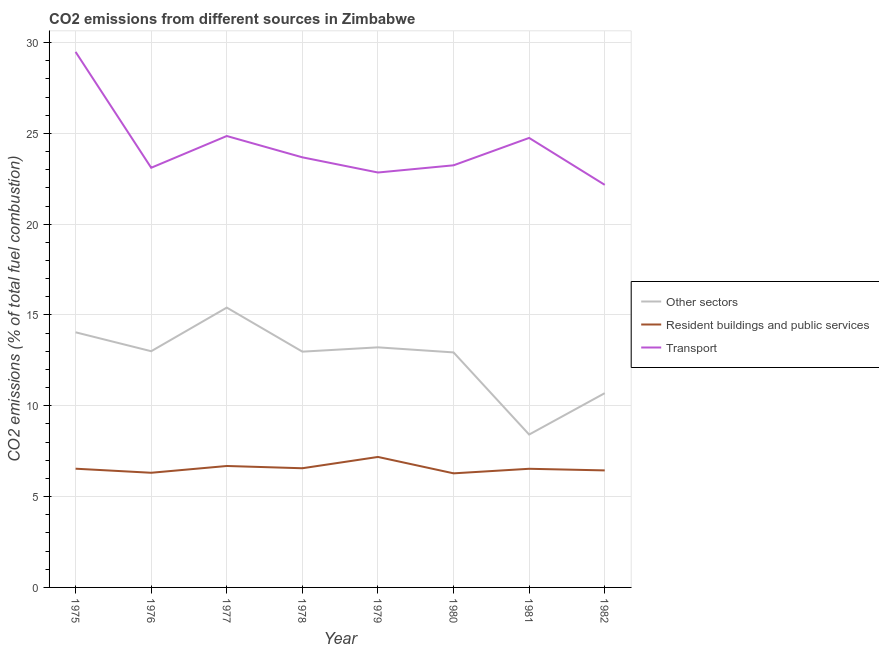Does the line corresponding to percentage of co2 emissions from other sectors intersect with the line corresponding to percentage of co2 emissions from resident buildings and public services?
Your answer should be compact. No. What is the percentage of co2 emissions from other sectors in 1977?
Your response must be concise. 15.41. Across all years, what is the maximum percentage of co2 emissions from other sectors?
Offer a terse response. 15.41. Across all years, what is the minimum percentage of co2 emissions from other sectors?
Your response must be concise. 8.42. In which year was the percentage of co2 emissions from transport maximum?
Provide a short and direct response. 1975. In which year was the percentage of co2 emissions from transport minimum?
Provide a short and direct response. 1982. What is the total percentage of co2 emissions from resident buildings and public services in the graph?
Offer a terse response. 52.54. What is the difference between the percentage of co2 emissions from transport in 1978 and that in 1982?
Give a very brief answer. 1.52. What is the difference between the percentage of co2 emissions from other sectors in 1981 and the percentage of co2 emissions from transport in 1982?
Keep it short and to the point. -13.75. What is the average percentage of co2 emissions from resident buildings and public services per year?
Your answer should be compact. 6.57. In the year 1975, what is the difference between the percentage of co2 emissions from resident buildings and public services and percentage of co2 emissions from other sectors?
Your answer should be very brief. -7.51. What is the ratio of the percentage of co2 emissions from resident buildings and public services in 1978 to that in 1981?
Provide a succinct answer. 1. Is the percentage of co2 emissions from transport in 1976 less than that in 1977?
Provide a short and direct response. Yes. Is the difference between the percentage of co2 emissions from resident buildings and public services in 1976 and 1981 greater than the difference between the percentage of co2 emissions from transport in 1976 and 1981?
Give a very brief answer. Yes. What is the difference between the highest and the second highest percentage of co2 emissions from resident buildings and public services?
Make the answer very short. 0.5. What is the difference between the highest and the lowest percentage of co2 emissions from transport?
Provide a short and direct response. 7.32. In how many years, is the percentage of co2 emissions from other sectors greater than the average percentage of co2 emissions from other sectors taken over all years?
Offer a very short reply. 6. Is it the case that in every year, the sum of the percentage of co2 emissions from other sectors and percentage of co2 emissions from resident buildings and public services is greater than the percentage of co2 emissions from transport?
Your response must be concise. No. Does the percentage of co2 emissions from resident buildings and public services monotonically increase over the years?
Offer a terse response. No. Is the percentage of co2 emissions from other sectors strictly less than the percentage of co2 emissions from transport over the years?
Your answer should be compact. Yes. How many lines are there?
Provide a succinct answer. 3. What is the difference between two consecutive major ticks on the Y-axis?
Your answer should be compact. 5. Are the values on the major ticks of Y-axis written in scientific E-notation?
Your response must be concise. No. Does the graph contain any zero values?
Offer a terse response. No. How are the legend labels stacked?
Keep it short and to the point. Vertical. What is the title of the graph?
Make the answer very short. CO2 emissions from different sources in Zimbabwe. What is the label or title of the Y-axis?
Offer a very short reply. CO2 emissions (% of total fuel combustion). What is the CO2 emissions (% of total fuel combustion) in Other sectors in 1975?
Keep it short and to the point. 14.05. What is the CO2 emissions (% of total fuel combustion) of Resident buildings and public services in 1975?
Your response must be concise. 6.54. What is the CO2 emissions (% of total fuel combustion) of Transport in 1975?
Keep it short and to the point. 29.49. What is the CO2 emissions (% of total fuel combustion) in Other sectors in 1976?
Provide a short and direct response. 13.01. What is the CO2 emissions (% of total fuel combustion) in Resident buildings and public services in 1976?
Provide a short and direct response. 6.31. What is the CO2 emissions (% of total fuel combustion) in Transport in 1976?
Keep it short and to the point. 23.11. What is the CO2 emissions (% of total fuel combustion) of Other sectors in 1977?
Your answer should be compact. 15.41. What is the CO2 emissions (% of total fuel combustion) in Resident buildings and public services in 1977?
Keep it short and to the point. 6.69. What is the CO2 emissions (% of total fuel combustion) of Transport in 1977?
Make the answer very short. 24.85. What is the CO2 emissions (% of total fuel combustion) in Other sectors in 1978?
Provide a short and direct response. 12.98. What is the CO2 emissions (% of total fuel combustion) in Resident buildings and public services in 1978?
Offer a very short reply. 6.56. What is the CO2 emissions (% of total fuel combustion) of Transport in 1978?
Provide a short and direct response. 23.68. What is the CO2 emissions (% of total fuel combustion) of Other sectors in 1979?
Keep it short and to the point. 13.22. What is the CO2 emissions (% of total fuel combustion) in Resident buildings and public services in 1979?
Your answer should be very brief. 7.18. What is the CO2 emissions (% of total fuel combustion) of Transport in 1979?
Your answer should be very brief. 22.84. What is the CO2 emissions (% of total fuel combustion) of Other sectors in 1980?
Make the answer very short. 12.94. What is the CO2 emissions (% of total fuel combustion) in Resident buildings and public services in 1980?
Offer a very short reply. 6.28. What is the CO2 emissions (% of total fuel combustion) in Transport in 1980?
Make the answer very short. 23.24. What is the CO2 emissions (% of total fuel combustion) of Other sectors in 1981?
Your response must be concise. 8.42. What is the CO2 emissions (% of total fuel combustion) of Resident buildings and public services in 1981?
Ensure brevity in your answer.  6.53. What is the CO2 emissions (% of total fuel combustion) in Transport in 1981?
Your response must be concise. 24.75. What is the CO2 emissions (% of total fuel combustion) of Other sectors in 1982?
Keep it short and to the point. 10.7. What is the CO2 emissions (% of total fuel combustion) of Resident buildings and public services in 1982?
Ensure brevity in your answer.  6.44. What is the CO2 emissions (% of total fuel combustion) in Transport in 1982?
Offer a very short reply. 22.16. Across all years, what is the maximum CO2 emissions (% of total fuel combustion) of Other sectors?
Your response must be concise. 15.41. Across all years, what is the maximum CO2 emissions (% of total fuel combustion) of Resident buildings and public services?
Make the answer very short. 7.18. Across all years, what is the maximum CO2 emissions (% of total fuel combustion) of Transport?
Your answer should be compact. 29.49. Across all years, what is the minimum CO2 emissions (% of total fuel combustion) of Other sectors?
Your answer should be very brief. 8.42. Across all years, what is the minimum CO2 emissions (% of total fuel combustion) in Resident buildings and public services?
Offer a very short reply. 6.28. Across all years, what is the minimum CO2 emissions (% of total fuel combustion) of Transport?
Ensure brevity in your answer.  22.16. What is the total CO2 emissions (% of total fuel combustion) of Other sectors in the graph?
Your response must be concise. 100.71. What is the total CO2 emissions (% of total fuel combustion) in Resident buildings and public services in the graph?
Your answer should be compact. 52.54. What is the total CO2 emissions (% of total fuel combustion) in Transport in the graph?
Offer a terse response. 194.13. What is the difference between the CO2 emissions (% of total fuel combustion) of Other sectors in 1975 and that in 1976?
Offer a very short reply. 1.04. What is the difference between the CO2 emissions (% of total fuel combustion) in Resident buildings and public services in 1975 and that in 1976?
Give a very brief answer. 0.22. What is the difference between the CO2 emissions (% of total fuel combustion) of Transport in 1975 and that in 1976?
Your answer should be very brief. 6.38. What is the difference between the CO2 emissions (% of total fuel combustion) in Other sectors in 1975 and that in 1977?
Make the answer very short. -1.36. What is the difference between the CO2 emissions (% of total fuel combustion) in Resident buildings and public services in 1975 and that in 1977?
Ensure brevity in your answer.  -0.15. What is the difference between the CO2 emissions (% of total fuel combustion) of Transport in 1975 and that in 1977?
Keep it short and to the point. 4.63. What is the difference between the CO2 emissions (% of total fuel combustion) of Other sectors in 1975 and that in 1978?
Offer a very short reply. 1.07. What is the difference between the CO2 emissions (% of total fuel combustion) of Resident buildings and public services in 1975 and that in 1978?
Provide a succinct answer. -0.03. What is the difference between the CO2 emissions (% of total fuel combustion) of Transport in 1975 and that in 1978?
Make the answer very short. 5.8. What is the difference between the CO2 emissions (% of total fuel combustion) in Other sectors in 1975 and that in 1979?
Provide a short and direct response. 0.83. What is the difference between the CO2 emissions (% of total fuel combustion) in Resident buildings and public services in 1975 and that in 1979?
Offer a terse response. -0.65. What is the difference between the CO2 emissions (% of total fuel combustion) of Transport in 1975 and that in 1979?
Make the answer very short. 6.64. What is the difference between the CO2 emissions (% of total fuel combustion) in Other sectors in 1975 and that in 1980?
Offer a very short reply. 1.11. What is the difference between the CO2 emissions (% of total fuel combustion) of Resident buildings and public services in 1975 and that in 1980?
Your answer should be very brief. 0.26. What is the difference between the CO2 emissions (% of total fuel combustion) of Transport in 1975 and that in 1980?
Your answer should be compact. 6.24. What is the difference between the CO2 emissions (% of total fuel combustion) of Other sectors in 1975 and that in 1981?
Ensure brevity in your answer.  5.63. What is the difference between the CO2 emissions (% of total fuel combustion) of Resident buildings and public services in 1975 and that in 1981?
Offer a terse response. 0. What is the difference between the CO2 emissions (% of total fuel combustion) in Transport in 1975 and that in 1981?
Your answer should be very brief. 4.74. What is the difference between the CO2 emissions (% of total fuel combustion) in Other sectors in 1975 and that in 1982?
Keep it short and to the point. 3.35. What is the difference between the CO2 emissions (% of total fuel combustion) in Resident buildings and public services in 1975 and that in 1982?
Your answer should be very brief. 0.09. What is the difference between the CO2 emissions (% of total fuel combustion) of Transport in 1975 and that in 1982?
Provide a succinct answer. 7.32. What is the difference between the CO2 emissions (% of total fuel combustion) of Other sectors in 1976 and that in 1977?
Your answer should be very brief. -2.4. What is the difference between the CO2 emissions (% of total fuel combustion) of Resident buildings and public services in 1976 and that in 1977?
Keep it short and to the point. -0.37. What is the difference between the CO2 emissions (% of total fuel combustion) of Transport in 1976 and that in 1977?
Your response must be concise. -1.75. What is the difference between the CO2 emissions (% of total fuel combustion) in Other sectors in 1976 and that in 1978?
Ensure brevity in your answer.  0.02. What is the difference between the CO2 emissions (% of total fuel combustion) in Resident buildings and public services in 1976 and that in 1978?
Offer a terse response. -0.25. What is the difference between the CO2 emissions (% of total fuel combustion) in Transport in 1976 and that in 1978?
Offer a very short reply. -0.57. What is the difference between the CO2 emissions (% of total fuel combustion) in Other sectors in 1976 and that in 1979?
Make the answer very short. -0.21. What is the difference between the CO2 emissions (% of total fuel combustion) in Resident buildings and public services in 1976 and that in 1979?
Your answer should be very brief. -0.87. What is the difference between the CO2 emissions (% of total fuel combustion) in Transport in 1976 and that in 1979?
Offer a terse response. 0.26. What is the difference between the CO2 emissions (% of total fuel combustion) in Other sectors in 1976 and that in 1980?
Your response must be concise. 0.07. What is the difference between the CO2 emissions (% of total fuel combustion) of Resident buildings and public services in 1976 and that in 1980?
Keep it short and to the point. 0.03. What is the difference between the CO2 emissions (% of total fuel combustion) of Transport in 1976 and that in 1980?
Provide a succinct answer. -0.14. What is the difference between the CO2 emissions (% of total fuel combustion) of Other sectors in 1976 and that in 1981?
Your answer should be compact. 4.59. What is the difference between the CO2 emissions (% of total fuel combustion) in Resident buildings and public services in 1976 and that in 1981?
Your answer should be compact. -0.22. What is the difference between the CO2 emissions (% of total fuel combustion) in Transport in 1976 and that in 1981?
Your answer should be compact. -1.64. What is the difference between the CO2 emissions (% of total fuel combustion) of Other sectors in 1976 and that in 1982?
Your answer should be compact. 2.31. What is the difference between the CO2 emissions (% of total fuel combustion) of Resident buildings and public services in 1976 and that in 1982?
Provide a short and direct response. -0.13. What is the difference between the CO2 emissions (% of total fuel combustion) in Transport in 1976 and that in 1982?
Offer a very short reply. 0.94. What is the difference between the CO2 emissions (% of total fuel combustion) in Other sectors in 1977 and that in 1978?
Offer a very short reply. 2.43. What is the difference between the CO2 emissions (% of total fuel combustion) of Resident buildings and public services in 1977 and that in 1978?
Provide a short and direct response. 0.12. What is the difference between the CO2 emissions (% of total fuel combustion) in Transport in 1977 and that in 1978?
Your response must be concise. 1.17. What is the difference between the CO2 emissions (% of total fuel combustion) in Other sectors in 1977 and that in 1979?
Your answer should be very brief. 2.19. What is the difference between the CO2 emissions (% of total fuel combustion) of Resident buildings and public services in 1977 and that in 1979?
Ensure brevity in your answer.  -0.5. What is the difference between the CO2 emissions (% of total fuel combustion) of Transport in 1977 and that in 1979?
Give a very brief answer. 2.01. What is the difference between the CO2 emissions (% of total fuel combustion) of Other sectors in 1977 and that in 1980?
Offer a terse response. 2.47. What is the difference between the CO2 emissions (% of total fuel combustion) of Resident buildings and public services in 1977 and that in 1980?
Provide a succinct answer. 0.4. What is the difference between the CO2 emissions (% of total fuel combustion) in Transport in 1977 and that in 1980?
Give a very brief answer. 1.61. What is the difference between the CO2 emissions (% of total fuel combustion) of Other sectors in 1977 and that in 1981?
Provide a short and direct response. 6.99. What is the difference between the CO2 emissions (% of total fuel combustion) in Resident buildings and public services in 1977 and that in 1981?
Make the answer very short. 0.15. What is the difference between the CO2 emissions (% of total fuel combustion) in Transport in 1977 and that in 1981?
Your answer should be compact. 0.11. What is the difference between the CO2 emissions (% of total fuel combustion) in Other sectors in 1977 and that in 1982?
Ensure brevity in your answer.  4.71. What is the difference between the CO2 emissions (% of total fuel combustion) of Resident buildings and public services in 1977 and that in 1982?
Give a very brief answer. 0.24. What is the difference between the CO2 emissions (% of total fuel combustion) of Transport in 1977 and that in 1982?
Offer a very short reply. 2.69. What is the difference between the CO2 emissions (% of total fuel combustion) in Other sectors in 1978 and that in 1979?
Keep it short and to the point. -0.24. What is the difference between the CO2 emissions (% of total fuel combustion) in Resident buildings and public services in 1978 and that in 1979?
Make the answer very short. -0.62. What is the difference between the CO2 emissions (% of total fuel combustion) of Transport in 1978 and that in 1979?
Your answer should be very brief. 0.84. What is the difference between the CO2 emissions (% of total fuel combustion) in Other sectors in 1978 and that in 1980?
Keep it short and to the point. 0.04. What is the difference between the CO2 emissions (% of total fuel combustion) of Resident buildings and public services in 1978 and that in 1980?
Ensure brevity in your answer.  0.28. What is the difference between the CO2 emissions (% of total fuel combustion) in Transport in 1978 and that in 1980?
Your answer should be compact. 0.44. What is the difference between the CO2 emissions (% of total fuel combustion) in Other sectors in 1978 and that in 1981?
Keep it short and to the point. 4.56. What is the difference between the CO2 emissions (% of total fuel combustion) in Resident buildings and public services in 1978 and that in 1981?
Your answer should be very brief. 0.03. What is the difference between the CO2 emissions (% of total fuel combustion) in Transport in 1978 and that in 1981?
Provide a succinct answer. -1.07. What is the difference between the CO2 emissions (% of total fuel combustion) of Other sectors in 1978 and that in 1982?
Make the answer very short. 2.29. What is the difference between the CO2 emissions (% of total fuel combustion) in Resident buildings and public services in 1978 and that in 1982?
Your answer should be compact. 0.12. What is the difference between the CO2 emissions (% of total fuel combustion) of Transport in 1978 and that in 1982?
Ensure brevity in your answer.  1.52. What is the difference between the CO2 emissions (% of total fuel combustion) in Other sectors in 1979 and that in 1980?
Your answer should be very brief. 0.28. What is the difference between the CO2 emissions (% of total fuel combustion) in Resident buildings and public services in 1979 and that in 1980?
Your answer should be very brief. 0.9. What is the difference between the CO2 emissions (% of total fuel combustion) in Transport in 1979 and that in 1980?
Your response must be concise. -0.4. What is the difference between the CO2 emissions (% of total fuel combustion) in Other sectors in 1979 and that in 1981?
Offer a terse response. 4.8. What is the difference between the CO2 emissions (% of total fuel combustion) in Resident buildings and public services in 1979 and that in 1981?
Provide a short and direct response. 0.65. What is the difference between the CO2 emissions (% of total fuel combustion) of Transport in 1979 and that in 1981?
Offer a very short reply. -1.9. What is the difference between the CO2 emissions (% of total fuel combustion) of Other sectors in 1979 and that in 1982?
Ensure brevity in your answer.  2.52. What is the difference between the CO2 emissions (% of total fuel combustion) in Resident buildings and public services in 1979 and that in 1982?
Give a very brief answer. 0.74. What is the difference between the CO2 emissions (% of total fuel combustion) in Transport in 1979 and that in 1982?
Keep it short and to the point. 0.68. What is the difference between the CO2 emissions (% of total fuel combustion) of Other sectors in 1980 and that in 1981?
Offer a terse response. 4.52. What is the difference between the CO2 emissions (% of total fuel combustion) of Resident buildings and public services in 1980 and that in 1981?
Offer a terse response. -0.25. What is the difference between the CO2 emissions (% of total fuel combustion) in Transport in 1980 and that in 1981?
Your response must be concise. -1.51. What is the difference between the CO2 emissions (% of total fuel combustion) in Other sectors in 1980 and that in 1982?
Offer a very short reply. 2.24. What is the difference between the CO2 emissions (% of total fuel combustion) of Resident buildings and public services in 1980 and that in 1982?
Provide a short and direct response. -0.16. What is the difference between the CO2 emissions (% of total fuel combustion) of Transport in 1980 and that in 1982?
Make the answer very short. 1.08. What is the difference between the CO2 emissions (% of total fuel combustion) of Other sectors in 1981 and that in 1982?
Provide a short and direct response. -2.28. What is the difference between the CO2 emissions (% of total fuel combustion) in Resident buildings and public services in 1981 and that in 1982?
Your answer should be very brief. 0.09. What is the difference between the CO2 emissions (% of total fuel combustion) in Transport in 1981 and that in 1982?
Offer a terse response. 2.58. What is the difference between the CO2 emissions (% of total fuel combustion) in Other sectors in 1975 and the CO2 emissions (% of total fuel combustion) in Resident buildings and public services in 1976?
Ensure brevity in your answer.  7.73. What is the difference between the CO2 emissions (% of total fuel combustion) in Other sectors in 1975 and the CO2 emissions (% of total fuel combustion) in Transport in 1976?
Ensure brevity in your answer.  -9.06. What is the difference between the CO2 emissions (% of total fuel combustion) of Resident buildings and public services in 1975 and the CO2 emissions (% of total fuel combustion) of Transport in 1976?
Provide a succinct answer. -16.57. What is the difference between the CO2 emissions (% of total fuel combustion) of Other sectors in 1975 and the CO2 emissions (% of total fuel combustion) of Resident buildings and public services in 1977?
Make the answer very short. 7.36. What is the difference between the CO2 emissions (% of total fuel combustion) in Other sectors in 1975 and the CO2 emissions (% of total fuel combustion) in Transport in 1977?
Give a very brief answer. -10.81. What is the difference between the CO2 emissions (% of total fuel combustion) in Resident buildings and public services in 1975 and the CO2 emissions (% of total fuel combustion) in Transport in 1977?
Your response must be concise. -18.32. What is the difference between the CO2 emissions (% of total fuel combustion) in Other sectors in 1975 and the CO2 emissions (% of total fuel combustion) in Resident buildings and public services in 1978?
Your response must be concise. 7.49. What is the difference between the CO2 emissions (% of total fuel combustion) of Other sectors in 1975 and the CO2 emissions (% of total fuel combustion) of Transport in 1978?
Offer a terse response. -9.63. What is the difference between the CO2 emissions (% of total fuel combustion) of Resident buildings and public services in 1975 and the CO2 emissions (% of total fuel combustion) of Transport in 1978?
Your answer should be compact. -17.14. What is the difference between the CO2 emissions (% of total fuel combustion) in Other sectors in 1975 and the CO2 emissions (% of total fuel combustion) in Resident buildings and public services in 1979?
Provide a succinct answer. 6.86. What is the difference between the CO2 emissions (% of total fuel combustion) in Other sectors in 1975 and the CO2 emissions (% of total fuel combustion) in Transport in 1979?
Your response must be concise. -8.8. What is the difference between the CO2 emissions (% of total fuel combustion) in Resident buildings and public services in 1975 and the CO2 emissions (% of total fuel combustion) in Transport in 1979?
Your answer should be compact. -16.31. What is the difference between the CO2 emissions (% of total fuel combustion) in Other sectors in 1975 and the CO2 emissions (% of total fuel combustion) in Resident buildings and public services in 1980?
Provide a short and direct response. 7.77. What is the difference between the CO2 emissions (% of total fuel combustion) in Other sectors in 1975 and the CO2 emissions (% of total fuel combustion) in Transport in 1980?
Your answer should be very brief. -9.19. What is the difference between the CO2 emissions (% of total fuel combustion) of Resident buildings and public services in 1975 and the CO2 emissions (% of total fuel combustion) of Transport in 1980?
Offer a terse response. -16.7. What is the difference between the CO2 emissions (% of total fuel combustion) in Other sectors in 1975 and the CO2 emissions (% of total fuel combustion) in Resident buildings and public services in 1981?
Ensure brevity in your answer.  7.51. What is the difference between the CO2 emissions (% of total fuel combustion) of Other sectors in 1975 and the CO2 emissions (% of total fuel combustion) of Transport in 1981?
Offer a terse response. -10.7. What is the difference between the CO2 emissions (% of total fuel combustion) of Resident buildings and public services in 1975 and the CO2 emissions (% of total fuel combustion) of Transport in 1981?
Offer a terse response. -18.21. What is the difference between the CO2 emissions (% of total fuel combustion) of Other sectors in 1975 and the CO2 emissions (% of total fuel combustion) of Resident buildings and public services in 1982?
Keep it short and to the point. 7.6. What is the difference between the CO2 emissions (% of total fuel combustion) of Other sectors in 1975 and the CO2 emissions (% of total fuel combustion) of Transport in 1982?
Ensure brevity in your answer.  -8.12. What is the difference between the CO2 emissions (% of total fuel combustion) of Resident buildings and public services in 1975 and the CO2 emissions (% of total fuel combustion) of Transport in 1982?
Your answer should be compact. -15.63. What is the difference between the CO2 emissions (% of total fuel combustion) in Other sectors in 1976 and the CO2 emissions (% of total fuel combustion) in Resident buildings and public services in 1977?
Your answer should be compact. 6.32. What is the difference between the CO2 emissions (% of total fuel combustion) in Other sectors in 1976 and the CO2 emissions (% of total fuel combustion) in Transport in 1977?
Make the answer very short. -11.85. What is the difference between the CO2 emissions (% of total fuel combustion) of Resident buildings and public services in 1976 and the CO2 emissions (% of total fuel combustion) of Transport in 1977?
Your response must be concise. -18.54. What is the difference between the CO2 emissions (% of total fuel combustion) in Other sectors in 1976 and the CO2 emissions (% of total fuel combustion) in Resident buildings and public services in 1978?
Offer a terse response. 6.44. What is the difference between the CO2 emissions (% of total fuel combustion) in Other sectors in 1976 and the CO2 emissions (% of total fuel combustion) in Transport in 1978?
Keep it short and to the point. -10.68. What is the difference between the CO2 emissions (% of total fuel combustion) of Resident buildings and public services in 1976 and the CO2 emissions (% of total fuel combustion) of Transport in 1978?
Your answer should be very brief. -17.37. What is the difference between the CO2 emissions (% of total fuel combustion) in Other sectors in 1976 and the CO2 emissions (% of total fuel combustion) in Resident buildings and public services in 1979?
Provide a succinct answer. 5.82. What is the difference between the CO2 emissions (% of total fuel combustion) in Other sectors in 1976 and the CO2 emissions (% of total fuel combustion) in Transport in 1979?
Offer a terse response. -9.84. What is the difference between the CO2 emissions (% of total fuel combustion) in Resident buildings and public services in 1976 and the CO2 emissions (% of total fuel combustion) in Transport in 1979?
Offer a very short reply. -16.53. What is the difference between the CO2 emissions (% of total fuel combustion) in Other sectors in 1976 and the CO2 emissions (% of total fuel combustion) in Resident buildings and public services in 1980?
Give a very brief answer. 6.72. What is the difference between the CO2 emissions (% of total fuel combustion) in Other sectors in 1976 and the CO2 emissions (% of total fuel combustion) in Transport in 1980?
Your answer should be compact. -10.24. What is the difference between the CO2 emissions (% of total fuel combustion) in Resident buildings and public services in 1976 and the CO2 emissions (% of total fuel combustion) in Transport in 1980?
Ensure brevity in your answer.  -16.93. What is the difference between the CO2 emissions (% of total fuel combustion) in Other sectors in 1976 and the CO2 emissions (% of total fuel combustion) in Resident buildings and public services in 1981?
Offer a very short reply. 6.47. What is the difference between the CO2 emissions (% of total fuel combustion) of Other sectors in 1976 and the CO2 emissions (% of total fuel combustion) of Transport in 1981?
Ensure brevity in your answer.  -11.74. What is the difference between the CO2 emissions (% of total fuel combustion) in Resident buildings and public services in 1976 and the CO2 emissions (% of total fuel combustion) in Transport in 1981?
Offer a terse response. -18.44. What is the difference between the CO2 emissions (% of total fuel combustion) in Other sectors in 1976 and the CO2 emissions (% of total fuel combustion) in Resident buildings and public services in 1982?
Offer a terse response. 6.56. What is the difference between the CO2 emissions (% of total fuel combustion) in Other sectors in 1976 and the CO2 emissions (% of total fuel combustion) in Transport in 1982?
Your answer should be compact. -9.16. What is the difference between the CO2 emissions (% of total fuel combustion) in Resident buildings and public services in 1976 and the CO2 emissions (% of total fuel combustion) in Transport in 1982?
Provide a succinct answer. -15.85. What is the difference between the CO2 emissions (% of total fuel combustion) in Other sectors in 1977 and the CO2 emissions (% of total fuel combustion) in Resident buildings and public services in 1978?
Offer a very short reply. 8.84. What is the difference between the CO2 emissions (% of total fuel combustion) of Other sectors in 1977 and the CO2 emissions (% of total fuel combustion) of Transport in 1978?
Your answer should be compact. -8.27. What is the difference between the CO2 emissions (% of total fuel combustion) in Resident buildings and public services in 1977 and the CO2 emissions (% of total fuel combustion) in Transport in 1978?
Make the answer very short. -16.99. What is the difference between the CO2 emissions (% of total fuel combustion) in Other sectors in 1977 and the CO2 emissions (% of total fuel combustion) in Resident buildings and public services in 1979?
Your response must be concise. 8.22. What is the difference between the CO2 emissions (% of total fuel combustion) in Other sectors in 1977 and the CO2 emissions (% of total fuel combustion) in Transport in 1979?
Your response must be concise. -7.44. What is the difference between the CO2 emissions (% of total fuel combustion) of Resident buildings and public services in 1977 and the CO2 emissions (% of total fuel combustion) of Transport in 1979?
Keep it short and to the point. -16.16. What is the difference between the CO2 emissions (% of total fuel combustion) of Other sectors in 1977 and the CO2 emissions (% of total fuel combustion) of Resident buildings and public services in 1980?
Make the answer very short. 9.13. What is the difference between the CO2 emissions (% of total fuel combustion) in Other sectors in 1977 and the CO2 emissions (% of total fuel combustion) in Transport in 1980?
Your response must be concise. -7.83. What is the difference between the CO2 emissions (% of total fuel combustion) in Resident buildings and public services in 1977 and the CO2 emissions (% of total fuel combustion) in Transport in 1980?
Keep it short and to the point. -16.56. What is the difference between the CO2 emissions (% of total fuel combustion) of Other sectors in 1977 and the CO2 emissions (% of total fuel combustion) of Resident buildings and public services in 1981?
Your response must be concise. 8.87. What is the difference between the CO2 emissions (% of total fuel combustion) of Other sectors in 1977 and the CO2 emissions (% of total fuel combustion) of Transport in 1981?
Keep it short and to the point. -9.34. What is the difference between the CO2 emissions (% of total fuel combustion) of Resident buildings and public services in 1977 and the CO2 emissions (% of total fuel combustion) of Transport in 1981?
Provide a succinct answer. -18.06. What is the difference between the CO2 emissions (% of total fuel combustion) of Other sectors in 1977 and the CO2 emissions (% of total fuel combustion) of Resident buildings and public services in 1982?
Offer a terse response. 8.96. What is the difference between the CO2 emissions (% of total fuel combustion) in Other sectors in 1977 and the CO2 emissions (% of total fuel combustion) in Transport in 1982?
Make the answer very short. -6.76. What is the difference between the CO2 emissions (% of total fuel combustion) in Resident buildings and public services in 1977 and the CO2 emissions (% of total fuel combustion) in Transport in 1982?
Provide a succinct answer. -15.48. What is the difference between the CO2 emissions (% of total fuel combustion) in Other sectors in 1978 and the CO2 emissions (% of total fuel combustion) in Resident buildings and public services in 1979?
Offer a very short reply. 5.8. What is the difference between the CO2 emissions (% of total fuel combustion) of Other sectors in 1978 and the CO2 emissions (% of total fuel combustion) of Transport in 1979?
Your answer should be very brief. -9.86. What is the difference between the CO2 emissions (% of total fuel combustion) in Resident buildings and public services in 1978 and the CO2 emissions (% of total fuel combustion) in Transport in 1979?
Provide a succinct answer. -16.28. What is the difference between the CO2 emissions (% of total fuel combustion) in Other sectors in 1978 and the CO2 emissions (% of total fuel combustion) in Resident buildings and public services in 1980?
Your answer should be very brief. 6.7. What is the difference between the CO2 emissions (% of total fuel combustion) in Other sectors in 1978 and the CO2 emissions (% of total fuel combustion) in Transport in 1980?
Your answer should be very brief. -10.26. What is the difference between the CO2 emissions (% of total fuel combustion) of Resident buildings and public services in 1978 and the CO2 emissions (% of total fuel combustion) of Transport in 1980?
Provide a succinct answer. -16.68. What is the difference between the CO2 emissions (% of total fuel combustion) of Other sectors in 1978 and the CO2 emissions (% of total fuel combustion) of Resident buildings and public services in 1981?
Offer a terse response. 6.45. What is the difference between the CO2 emissions (% of total fuel combustion) in Other sectors in 1978 and the CO2 emissions (% of total fuel combustion) in Transport in 1981?
Offer a very short reply. -11.77. What is the difference between the CO2 emissions (% of total fuel combustion) of Resident buildings and public services in 1978 and the CO2 emissions (% of total fuel combustion) of Transport in 1981?
Provide a short and direct response. -18.19. What is the difference between the CO2 emissions (% of total fuel combustion) in Other sectors in 1978 and the CO2 emissions (% of total fuel combustion) in Resident buildings and public services in 1982?
Your answer should be very brief. 6.54. What is the difference between the CO2 emissions (% of total fuel combustion) in Other sectors in 1978 and the CO2 emissions (% of total fuel combustion) in Transport in 1982?
Ensure brevity in your answer.  -9.18. What is the difference between the CO2 emissions (% of total fuel combustion) in Resident buildings and public services in 1978 and the CO2 emissions (% of total fuel combustion) in Transport in 1982?
Provide a succinct answer. -15.6. What is the difference between the CO2 emissions (% of total fuel combustion) of Other sectors in 1979 and the CO2 emissions (% of total fuel combustion) of Resident buildings and public services in 1980?
Give a very brief answer. 6.94. What is the difference between the CO2 emissions (% of total fuel combustion) in Other sectors in 1979 and the CO2 emissions (% of total fuel combustion) in Transport in 1980?
Provide a short and direct response. -10.02. What is the difference between the CO2 emissions (% of total fuel combustion) of Resident buildings and public services in 1979 and the CO2 emissions (% of total fuel combustion) of Transport in 1980?
Your answer should be compact. -16.06. What is the difference between the CO2 emissions (% of total fuel combustion) of Other sectors in 1979 and the CO2 emissions (% of total fuel combustion) of Resident buildings and public services in 1981?
Offer a terse response. 6.69. What is the difference between the CO2 emissions (% of total fuel combustion) of Other sectors in 1979 and the CO2 emissions (% of total fuel combustion) of Transport in 1981?
Offer a very short reply. -11.53. What is the difference between the CO2 emissions (% of total fuel combustion) in Resident buildings and public services in 1979 and the CO2 emissions (% of total fuel combustion) in Transport in 1981?
Keep it short and to the point. -17.56. What is the difference between the CO2 emissions (% of total fuel combustion) in Other sectors in 1979 and the CO2 emissions (% of total fuel combustion) in Resident buildings and public services in 1982?
Your answer should be very brief. 6.78. What is the difference between the CO2 emissions (% of total fuel combustion) of Other sectors in 1979 and the CO2 emissions (% of total fuel combustion) of Transport in 1982?
Give a very brief answer. -8.95. What is the difference between the CO2 emissions (% of total fuel combustion) of Resident buildings and public services in 1979 and the CO2 emissions (% of total fuel combustion) of Transport in 1982?
Your answer should be very brief. -14.98. What is the difference between the CO2 emissions (% of total fuel combustion) in Other sectors in 1980 and the CO2 emissions (% of total fuel combustion) in Resident buildings and public services in 1981?
Provide a succinct answer. 6.41. What is the difference between the CO2 emissions (% of total fuel combustion) in Other sectors in 1980 and the CO2 emissions (% of total fuel combustion) in Transport in 1981?
Provide a succinct answer. -11.81. What is the difference between the CO2 emissions (% of total fuel combustion) of Resident buildings and public services in 1980 and the CO2 emissions (% of total fuel combustion) of Transport in 1981?
Your answer should be compact. -18.47. What is the difference between the CO2 emissions (% of total fuel combustion) of Other sectors in 1980 and the CO2 emissions (% of total fuel combustion) of Resident buildings and public services in 1982?
Provide a short and direct response. 6.5. What is the difference between the CO2 emissions (% of total fuel combustion) in Other sectors in 1980 and the CO2 emissions (% of total fuel combustion) in Transport in 1982?
Offer a terse response. -9.23. What is the difference between the CO2 emissions (% of total fuel combustion) of Resident buildings and public services in 1980 and the CO2 emissions (% of total fuel combustion) of Transport in 1982?
Provide a succinct answer. -15.88. What is the difference between the CO2 emissions (% of total fuel combustion) in Other sectors in 1981 and the CO2 emissions (% of total fuel combustion) in Resident buildings and public services in 1982?
Ensure brevity in your answer.  1.97. What is the difference between the CO2 emissions (% of total fuel combustion) in Other sectors in 1981 and the CO2 emissions (% of total fuel combustion) in Transport in 1982?
Provide a short and direct response. -13.75. What is the difference between the CO2 emissions (% of total fuel combustion) of Resident buildings and public services in 1981 and the CO2 emissions (% of total fuel combustion) of Transport in 1982?
Give a very brief answer. -15.63. What is the average CO2 emissions (% of total fuel combustion) in Other sectors per year?
Make the answer very short. 12.59. What is the average CO2 emissions (% of total fuel combustion) of Resident buildings and public services per year?
Your response must be concise. 6.57. What is the average CO2 emissions (% of total fuel combustion) of Transport per year?
Give a very brief answer. 24.27. In the year 1975, what is the difference between the CO2 emissions (% of total fuel combustion) of Other sectors and CO2 emissions (% of total fuel combustion) of Resident buildings and public services?
Offer a very short reply. 7.51. In the year 1975, what is the difference between the CO2 emissions (% of total fuel combustion) in Other sectors and CO2 emissions (% of total fuel combustion) in Transport?
Your response must be concise. -15.44. In the year 1975, what is the difference between the CO2 emissions (% of total fuel combustion) of Resident buildings and public services and CO2 emissions (% of total fuel combustion) of Transport?
Your response must be concise. -22.95. In the year 1976, what is the difference between the CO2 emissions (% of total fuel combustion) in Other sectors and CO2 emissions (% of total fuel combustion) in Resident buildings and public services?
Give a very brief answer. 6.69. In the year 1976, what is the difference between the CO2 emissions (% of total fuel combustion) in Other sectors and CO2 emissions (% of total fuel combustion) in Transport?
Your answer should be very brief. -10.1. In the year 1976, what is the difference between the CO2 emissions (% of total fuel combustion) of Resident buildings and public services and CO2 emissions (% of total fuel combustion) of Transport?
Provide a short and direct response. -16.79. In the year 1977, what is the difference between the CO2 emissions (% of total fuel combustion) of Other sectors and CO2 emissions (% of total fuel combustion) of Resident buildings and public services?
Ensure brevity in your answer.  8.72. In the year 1977, what is the difference between the CO2 emissions (% of total fuel combustion) in Other sectors and CO2 emissions (% of total fuel combustion) in Transport?
Ensure brevity in your answer.  -9.45. In the year 1977, what is the difference between the CO2 emissions (% of total fuel combustion) in Resident buildings and public services and CO2 emissions (% of total fuel combustion) in Transport?
Provide a succinct answer. -18.17. In the year 1978, what is the difference between the CO2 emissions (% of total fuel combustion) in Other sectors and CO2 emissions (% of total fuel combustion) in Resident buildings and public services?
Make the answer very short. 6.42. In the year 1978, what is the difference between the CO2 emissions (% of total fuel combustion) of Other sectors and CO2 emissions (% of total fuel combustion) of Transport?
Ensure brevity in your answer.  -10.7. In the year 1978, what is the difference between the CO2 emissions (% of total fuel combustion) of Resident buildings and public services and CO2 emissions (% of total fuel combustion) of Transport?
Make the answer very short. -17.12. In the year 1979, what is the difference between the CO2 emissions (% of total fuel combustion) of Other sectors and CO2 emissions (% of total fuel combustion) of Resident buildings and public services?
Ensure brevity in your answer.  6.03. In the year 1979, what is the difference between the CO2 emissions (% of total fuel combustion) in Other sectors and CO2 emissions (% of total fuel combustion) in Transport?
Provide a short and direct response. -9.63. In the year 1979, what is the difference between the CO2 emissions (% of total fuel combustion) in Resident buildings and public services and CO2 emissions (% of total fuel combustion) in Transport?
Keep it short and to the point. -15.66. In the year 1980, what is the difference between the CO2 emissions (% of total fuel combustion) in Other sectors and CO2 emissions (% of total fuel combustion) in Resident buildings and public services?
Your answer should be compact. 6.66. In the year 1980, what is the difference between the CO2 emissions (% of total fuel combustion) of Other sectors and CO2 emissions (% of total fuel combustion) of Transport?
Provide a succinct answer. -10.3. In the year 1980, what is the difference between the CO2 emissions (% of total fuel combustion) in Resident buildings and public services and CO2 emissions (% of total fuel combustion) in Transport?
Your answer should be compact. -16.96. In the year 1981, what is the difference between the CO2 emissions (% of total fuel combustion) in Other sectors and CO2 emissions (% of total fuel combustion) in Resident buildings and public services?
Provide a short and direct response. 1.88. In the year 1981, what is the difference between the CO2 emissions (% of total fuel combustion) in Other sectors and CO2 emissions (% of total fuel combustion) in Transport?
Ensure brevity in your answer.  -16.33. In the year 1981, what is the difference between the CO2 emissions (% of total fuel combustion) in Resident buildings and public services and CO2 emissions (% of total fuel combustion) in Transport?
Give a very brief answer. -18.22. In the year 1982, what is the difference between the CO2 emissions (% of total fuel combustion) in Other sectors and CO2 emissions (% of total fuel combustion) in Resident buildings and public services?
Ensure brevity in your answer.  4.25. In the year 1982, what is the difference between the CO2 emissions (% of total fuel combustion) in Other sectors and CO2 emissions (% of total fuel combustion) in Transport?
Your answer should be very brief. -11.47. In the year 1982, what is the difference between the CO2 emissions (% of total fuel combustion) of Resident buildings and public services and CO2 emissions (% of total fuel combustion) of Transport?
Ensure brevity in your answer.  -15.72. What is the ratio of the CO2 emissions (% of total fuel combustion) in Other sectors in 1975 to that in 1976?
Your response must be concise. 1.08. What is the ratio of the CO2 emissions (% of total fuel combustion) of Resident buildings and public services in 1975 to that in 1976?
Your answer should be very brief. 1.04. What is the ratio of the CO2 emissions (% of total fuel combustion) in Transport in 1975 to that in 1976?
Offer a terse response. 1.28. What is the ratio of the CO2 emissions (% of total fuel combustion) of Other sectors in 1975 to that in 1977?
Offer a terse response. 0.91. What is the ratio of the CO2 emissions (% of total fuel combustion) of Resident buildings and public services in 1975 to that in 1977?
Make the answer very short. 0.98. What is the ratio of the CO2 emissions (% of total fuel combustion) of Transport in 1975 to that in 1977?
Provide a succinct answer. 1.19. What is the ratio of the CO2 emissions (% of total fuel combustion) of Other sectors in 1975 to that in 1978?
Your answer should be very brief. 1.08. What is the ratio of the CO2 emissions (% of total fuel combustion) of Resident buildings and public services in 1975 to that in 1978?
Provide a short and direct response. 1. What is the ratio of the CO2 emissions (% of total fuel combustion) in Transport in 1975 to that in 1978?
Your answer should be compact. 1.25. What is the ratio of the CO2 emissions (% of total fuel combustion) in Other sectors in 1975 to that in 1979?
Offer a terse response. 1.06. What is the ratio of the CO2 emissions (% of total fuel combustion) in Resident buildings and public services in 1975 to that in 1979?
Offer a very short reply. 0.91. What is the ratio of the CO2 emissions (% of total fuel combustion) in Transport in 1975 to that in 1979?
Provide a short and direct response. 1.29. What is the ratio of the CO2 emissions (% of total fuel combustion) of Other sectors in 1975 to that in 1980?
Give a very brief answer. 1.09. What is the ratio of the CO2 emissions (% of total fuel combustion) in Resident buildings and public services in 1975 to that in 1980?
Give a very brief answer. 1.04. What is the ratio of the CO2 emissions (% of total fuel combustion) in Transport in 1975 to that in 1980?
Your answer should be compact. 1.27. What is the ratio of the CO2 emissions (% of total fuel combustion) in Other sectors in 1975 to that in 1981?
Provide a succinct answer. 1.67. What is the ratio of the CO2 emissions (% of total fuel combustion) of Transport in 1975 to that in 1981?
Give a very brief answer. 1.19. What is the ratio of the CO2 emissions (% of total fuel combustion) in Other sectors in 1975 to that in 1982?
Offer a terse response. 1.31. What is the ratio of the CO2 emissions (% of total fuel combustion) in Resident buildings and public services in 1975 to that in 1982?
Make the answer very short. 1.01. What is the ratio of the CO2 emissions (% of total fuel combustion) of Transport in 1975 to that in 1982?
Your response must be concise. 1.33. What is the ratio of the CO2 emissions (% of total fuel combustion) of Other sectors in 1976 to that in 1977?
Your answer should be compact. 0.84. What is the ratio of the CO2 emissions (% of total fuel combustion) of Resident buildings and public services in 1976 to that in 1977?
Ensure brevity in your answer.  0.94. What is the ratio of the CO2 emissions (% of total fuel combustion) in Transport in 1976 to that in 1977?
Make the answer very short. 0.93. What is the ratio of the CO2 emissions (% of total fuel combustion) of Other sectors in 1976 to that in 1978?
Offer a terse response. 1. What is the ratio of the CO2 emissions (% of total fuel combustion) in Resident buildings and public services in 1976 to that in 1978?
Keep it short and to the point. 0.96. What is the ratio of the CO2 emissions (% of total fuel combustion) in Transport in 1976 to that in 1978?
Provide a succinct answer. 0.98. What is the ratio of the CO2 emissions (% of total fuel combustion) in Other sectors in 1976 to that in 1979?
Offer a very short reply. 0.98. What is the ratio of the CO2 emissions (% of total fuel combustion) of Resident buildings and public services in 1976 to that in 1979?
Provide a short and direct response. 0.88. What is the ratio of the CO2 emissions (% of total fuel combustion) in Transport in 1976 to that in 1979?
Ensure brevity in your answer.  1.01. What is the ratio of the CO2 emissions (% of total fuel combustion) of Other sectors in 1976 to that in 1980?
Make the answer very short. 1.01. What is the ratio of the CO2 emissions (% of total fuel combustion) in Transport in 1976 to that in 1980?
Give a very brief answer. 0.99. What is the ratio of the CO2 emissions (% of total fuel combustion) in Other sectors in 1976 to that in 1981?
Offer a very short reply. 1.55. What is the ratio of the CO2 emissions (% of total fuel combustion) of Resident buildings and public services in 1976 to that in 1981?
Provide a short and direct response. 0.97. What is the ratio of the CO2 emissions (% of total fuel combustion) of Transport in 1976 to that in 1981?
Provide a succinct answer. 0.93. What is the ratio of the CO2 emissions (% of total fuel combustion) of Other sectors in 1976 to that in 1982?
Keep it short and to the point. 1.22. What is the ratio of the CO2 emissions (% of total fuel combustion) of Resident buildings and public services in 1976 to that in 1982?
Make the answer very short. 0.98. What is the ratio of the CO2 emissions (% of total fuel combustion) of Transport in 1976 to that in 1982?
Provide a short and direct response. 1.04. What is the ratio of the CO2 emissions (% of total fuel combustion) in Other sectors in 1977 to that in 1978?
Offer a very short reply. 1.19. What is the ratio of the CO2 emissions (% of total fuel combustion) in Resident buildings and public services in 1977 to that in 1978?
Your answer should be very brief. 1.02. What is the ratio of the CO2 emissions (% of total fuel combustion) in Transport in 1977 to that in 1978?
Provide a short and direct response. 1.05. What is the ratio of the CO2 emissions (% of total fuel combustion) of Other sectors in 1977 to that in 1979?
Make the answer very short. 1.17. What is the ratio of the CO2 emissions (% of total fuel combustion) of Resident buildings and public services in 1977 to that in 1979?
Offer a terse response. 0.93. What is the ratio of the CO2 emissions (% of total fuel combustion) in Transport in 1977 to that in 1979?
Ensure brevity in your answer.  1.09. What is the ratio of the CO2 emissions (% of total fuel combustion) in Other sectors in 1977 to that in 1980?
Keep it short and to the point. 1.19. What is the ratio of the CO2 emissions (% of total fuel combustion) of Resident buildings and public services in 1977 to that in 1980?
Provide a succinct answer. 1.06. What is the ratio of the CO2 emissions (% of total fuel combustion) of Transport in 1977 to that in 1980?
Your response must be concise. 1.07. What is the ratio of the CO2 emissions (% of total fuel combustion) in Other sectors in 1977 to that in 1981?
Provide a succinct answer. 1.83. What is the ratio of the CO2 emissions (% of total fuel combustion) of Resident buildings and public services in 1977 to that in 1981?
Your answer should be compact. 1.02. What is the ratio of the CO2 emissions (% of total fuel combustion) in Transport in 1977 to that in 1981?
Give a very brief answer. 1. What is the ratio of the CO2 emissions (% of total fuel combustion) in Other sectors in 1977 to that in 1982?
Your answer should be compact. 1.44. What is the ratio of the CO2 emissions (% of total fuel combustion) of Resident buildings and public services in 1977 to that in 1982?
Offer a very short reply. 1.04. What is the ratio of the CO2 emissions (% of total fuel combustion) in Transport in 1977 to that in 1982?
Keep it short and to the point. 1.12. What is the ratio of the CO2 emissions (% of total fuel combustion) in Other sectors in 1978 to that in 1979?
Provide a succinct answer. 0.98. What is the ratio of the CO2 emissions (% of total fuel combustion) in Resident buildings and public services in 1978 to that in 1979?
Provide a succinct answer. 0.91. What is the ratio of the CO2 emissions (% of total fuel combustion) in Transport in 1978 to that in 1979?
Give a very brief answer. 1.04. What is the ratio of the CO2 emissions (% of total fuel combustion) of Resident buildings and public services in 1978 to that in 1980?
Your response must be concise. 1.04. What is the ratio of the CO2 emissions (% of total fuel combustion) of Transport in 1978 to that in 1980?
Offer a very short reply. 1.02. What is the ratio of the CO2 emissions (% of total fuel combustion) in Other sectors in 1978 to that in 1981?
Provide a short and direct response. 1.54. What is the ratio of the CO2 emissions (% of total fuel combustion) in Transport in 1978 to that in 1981?
Provide a succinct answer. 0.96. What is the ratio of the CO2 emissions (% of total fuel combustion) in Other sectors in 1978 to that in 1982?
Offer a very short reply. 1.21. What is the ratio of the CO2 emissions (% of total fuel combustion) in Resident buildings and public services in 1978 to that in 1982?
Give a very brief answer. 1.02. What is the ratio of the CO2 emissions (% of total fuel combustion) in Transport in 1978 to that in 1982?
Provide a succinct answer. 1.07. What is the ratio of the CO2 emissions (% of total fuel combustion) of Other sectors in 1979 to that in 1980?
Offer a very short reply. 1.02. What is the ratio of the CO2 emissions (% of total fuel combustion) in Resident buildings and public services in 1979 to that in 1980?
Your answer should be compact. 1.14. What is the ratio of the CO2 emissions (% of total fuel combustion) of Transport in 1979 to that in 1980?
Provide a short and direct response. 0.98. What is the ratio of the CO2 emissions (% of total fuel combustion) of Other sectors in 1979 to that in 1981?
Offer a terse response. 1.57. What is the ratio of the CO2 emissions (% of total fuel combustion) in Resident buildings and public services in 1979 to that in 1981?
Your answer should be very brief. 1.1. What is the ratio of the CO2 emissions (% of total fuel combustion) of Other sectors in 1979 to that in 1982?
Provide a succinct answer. 1.24. What is the ratio of the CO2 emissions (% of total fuel combustion) of Resident buildings and public services in 1979 to that in 1982?
Make the answer very short. 1.11. What is the ratio of the CO2 emissions (% of total fuel combustion) in Transport in 1979 to that in 1982?
Offer a very short reply. 1.03. What is the ratio of the CO2 emissions (% of total fuel combustion) in Other sectors in 1980 to that in 1981?
Provide a short and direct response. 1.54. What is the ratio of the CO2 emissions (% of total fuel combustion) of Resident buildings and public services in 1980 to that in 1981?
Your response must be concise. 0.96. What is the ratio of the CO2 emissions (% of total fuel combustion) of Transport in 1980 to that in 1981?
Your response must be concise. 0.94. What is the ratio of the CO2 emissions (% of total fuel combustion) of Other sectors in 1980 to that in 1982?
Your response must be concise. 1.21. What is the ratio of the CO2 emissions (% of total fuel combustion) in Resident buildings and public services in 1980 to that in 1982?
Your answer should be compact. 0.97. What is the ratio of the CO2 emissions (% of total fuel combustion) in Transport in 1980 to that in 1982?
Ensure brevity in your answer.  1.05. What is the ratio of the CO2 emissions (% of total fuel combustion) in Other sectors in 1981 to that in 1982?
Offer a terse response. 0.79. What is the ratio of the CO2 emissions (% of total fuel combustion) of Resident buildings and public services in 1981 to that in 1982?
Your answer should be very brief. 1.01. What is the ratio of the CO2 emissions (% of total fuel combustion) of Transport in 1981 to that in 1982?
Provide a short and direct response. 1.12. What is the difference between the highest and the second highest CO2 emissions (% of total fuel combustion) in Other sectors?
Your answer should be very brief. 1.36. What is the difference between the highest and the second highest CO2 emissions (% of total fuel combustion) of Resident buildings and public services?
Make the answer very short. 0.5. What is the difference between the highest and the second highest CO2 emissions (% of total fuel combustion) of Transport?
Your answer should be very brief. 4.63. What is the difference between the highest and the lowest CO2 emissions (% of total fuel combustion) in Other sectors?
Offer a terse response. 6.99. What is the difference between the highest and the lowest CO2 emissions (% of total fuel combustion) in Resident buildings and public services?
Offer a very short reply. 0.9. What is the difference between the highest and the lowest CO2 emissions (% of total fuel combustion) in Transport?
Offer a terse response. 7.32. 